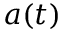Convert formula to latex. <formula><loc_0><loc_0><loc_500><loc_500>a ( t )</formula> 